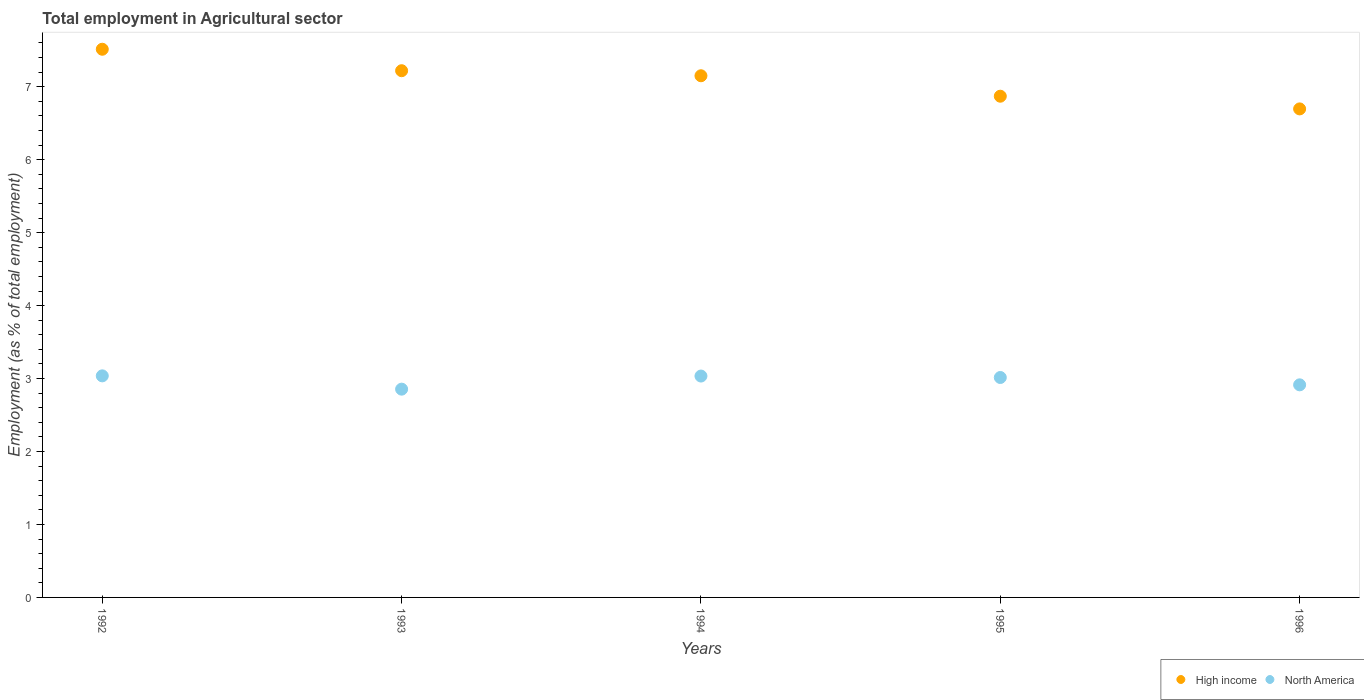How many different coloured dotlines are there?
Your answer should be compact. 2. Is the number of dotlines equal to the number of legend labels?
Provide a short and direct response. Yes. What is the employment in agricultural sector in High income in 1994?
Your response must be concise. 7.15. Across all years, what is the maximum employment in agricultural sector in North America?
Your answer should be compact. 3.04. Across all years, what is the minimum employment in agricultural sector in High income?
Keep it short and to the point. 6.7. What is the total employment in agricultural sector in North America in the graph?
Offer a terse response. 14.85. What is the difference between the employment in agricultural sector in High income in 1993 and that in 1994?
Offer a very short reply. 0.07. What is the difference between the employment in agricultural sector in High income in 1993 and the employment in agricultural sector in North America in 1995?
Your answer should be very brief. 4.21. What is the average employment in agricultural sector in North America per year?
Offer a terse response. 2.97. In the year 1993, what is the difference between the employment in agricultural sector in High income and employment in agricultural sector in North America?
Keep it short and to the point. 4.36. What is the ratio of the employment in agricultural sector in North America in 1992 to that in 1994?
Your answer should be compact. 1. What is the difference between the highest and the second highest employment in agricultural sector in North America?
Your answer should be compact. 0. What is the difference between the highest and the lowest employment in agricultural sector in High income?
Provide a short and direct response. 0.82. In how many years, is the employment in agricultural sector in High income greater than the average employment in agricultural sector in High income taken over all years?
Offer a terse response. 3. How many years are there in the graph?
Provide a short and direct response. 5. What is the difference between two consecutive major ticks on the Y-axis?
Provide a succinct answer. 1. Are the values on the major ticks of Y-axis written in scientific E-notation?
Your response must be concise. No. How many legend labels are there?
Offer a very short reply. 2. What is the title of the graph?
Ensure brevity in your answer.  Total employment in Agricultural sector. What is the label or title of the Y-axis?
Offer a very short reply. Employment (as % of total employment). What is the Employment (as % of total employment) in High income in 1992?
Provide a short and direct response. 7.51. What is the Employment (as % of total employment) in North America in 1992?
Keep it short and to the point. 3.04. What is the Employment (as % of total employment) of High income in 1993?
Ensure brevity in your answer.  7.22. What is the Employment (as % of total employment) of North America in 1993?
Make the answer very short. 2.85. What is the Employment (as % of total employment) of High income in 1994?
Provide a short and direct response. 7.15. What is the Employment (as % of total employment) in North America in 1994?
Your answer should be compact. 3.03. What is the Employment (as % of total employment) in High income in 1995?
Give a very brief answer. 6.87. What is the Employment (as % of total employment) in North America in 1995?
Give a very brief answer. 3.01. What is the Employment (as % of total employment) in High income in 1996?
Keep it short and to the point. 6.7. What is the Employment (as % of total employment) in North America in 1996?
Offer a very short reply. 2.91. Across all years, what is the maximum Employment (as % of total employment) in High income?
Keep it short and to the point. 7.51. Across all years, what is the maximum Employment (as % of total employment) of North America?
Provide a succinct answer. 3.04. Across all years, what is the minimum Employment (as % of total employment) of High income?
Your response must be concise. 6.7. Across all years, what is the minimum Employment (as % of total employment) of North America?
Keep it short and to the point. 2.85. What is the total Employment (as % of total employment) of High income in the graph?
Your answer should be very brief. 35.45. What is the total Employment (as % of total employment) in North America in the graph?
Your answer should be very brief. 14.85. What is the difference between the Employment (as % of total employment) in High income in 1992 and that in 1993?
Give a very brief answer. 0.29. What is the difference between the Employment (as % of total employment) of North America in 1992 and that in 1993?
Offer a very short reply. 0.18. What is the difference between the Employment (as % of total employment) in High income in 1992 and that in 1994?
Provide a succinct answer. 0.36. What is the difference between the Employment (as % of total employment) of North America in 1992 and that in 1994?
Your answer should be very brief. 0. What is the difference between the Employment (as % of total employment) of High income in 1992 and that in 1995?
Keep it short and to the point. 0.64. What is the difference between the Employment (as % of total employment) in North America in 1992 and that in 1995?
Your response must be concise. 0.02. What is the difference between the Employment (as % of total employment) of High income in 1992 and that in 1996?
Your response must be concise. 0.82. What is the difference between the Employment (as % of total employment) of North America in 1992 and that in 1996?
Provide a succinct answer. 0.12. What is the difference between the Employment (as % of total employment) in High income in 1993 and that in 1994?
Offer a very short reply. 0.07. What is the difference between the Employment (as % of total employment) of North America in 1993 and that in 1994?
Offer a terse response. -0.18. What is the difference between the Employment (as % of total employment) in High income in 1993 and that in 1995?
Make the answer very short. 0.35. What is the difference between the Employment (as % of total employment) in North America in 1993 and that in 1995?
Offer a terse response. -0.16. What is the difference between the Employment (as % of total employment) of High income in 1993 and that in 1996?
Your answer should be compact. 0.52. What is the difference between the Employment (as % of total employment) of North America in 1993 and that in 1996?
Offer a terse response. -0.06. What is the difference between the Employment (as % of total employment) in High income in 1994 and that in 1995?
Your response must be concise. 0.28. What is the difference between the Employment (as % of total employment) in North America in 1994 and that in 1995?
Offer a very short reply. 0.02. What is the difference between the Employment (as % of total employment) in High income in 1994 and that in 1996?
Your response must be concise. 0.45. What is the difference between the Employment (as % of total employment) in North America in 1994 and that in 1996?
Your answer should be very brief. 0.12. What is the difference between the Employment (as % of total employment) of High income in 1995 and that in 1996?
Keep it short and to the point. 0.17. What is the difference between the Employment (as % of total employment) in North America in 1995 and that in 1996?
Ensure brevity in your answer.  0.1. What is the difference between the Employment (as % of total employment) of High income in 1992 and the Employment (as % of total employment) of North America in 1993?
Offer a terse response. 4.66. What is the difference between the Employment (as % of total employment) of High income in 1992 and the Employment (as % of total employment) of North America in 1994?
Your response must be concise. 4.48. What is the difference between the Employment (as % of total employment) of High income in 1992 and the Employment (as % of total employment) of North America in 1995?
Your response must be concise. 4.5. What is the difference between the Employment (as % of total employment) of High income in 1992 and the Employment (as % of total employment) of North America in 1996?
Make the answer very short. 4.6. What is the difference between the Employment (as % of total employment) in High income in 1993 and the Employment (as % of total employment) in North America in 1994?
Make the answer very short. 4.19. What is the difference between the Employment (as % of total employment) of High income in 1993 and the Employment (as % of total employment) of North America in 1995?
Keep it short and to the point. 4.21. What is the difference between the Employment (as % of total employment) in High income in 1993 and the Employment (as % of total employment) in North America in 1996?
Ensure brevity in your answer.  4.31. What is the difference between the Employment (as % of total employment) in High income in 1994 and the Employment (as % of total employment) in North America in 1995?
Make the answer very short. 4.14. What is the difference between the Employment (as % of total employment) of High income in 1994 and the Employment (as % of total employment) of North America in 1996?
Provide a succinct answer. 4.24. What is the difference between the Employment (as % of total employment) of High income in 1995 and the Employment (as % of total employment) of North America in 1996?
Make the answer very short. 3.96. What is the average Employment (as % of total employment) in High income per year?
Your response must be concise. 7.09. What is the average Employment (as % of total employment) in North America per year?
Ensure brevity in your answer.  2.97. In the year 1992, what is the difference between the Employment (as % of total employment) in High income and Employment (as % of total employment) in North America?
Ensure brevity in your answer.  4.48. In the year 1993, what is the difference between the Employment (as % of total employment) of High income and Employment (as % of total employment) of North America?
Offer a terse response. 4.36. In the year 1994, what is the difference between the Employment (as % of total employment) in High income and Employment (as % of total employment) in North America?
Offer a terse response. 4.12. In the year 1995, what is the difference between the Employment (as % of total employment) in High income and Employment (as % of total employment) in North America?
Offer a terse response. 3.86. In the year 1996, what is the difference between the Employment (as % of total employment) of High income and Employment (as % of total employment) of North America?
Ensure brevity in your answer.  3.78. What is the ratio of the Employment (as % of total employment) of High income in 1992 to that in 1993?
Your answer should be very brief. 1.04. What is the ratio of the Employment (as % of total employment) of North America in 1992 to that in 1993?
Your response must be concise. 1.06. What is the ratio of the Employment (as % of total employment) of High income in 1992 to that in 1994?
Offer a terse response. 1.05. What is the ratio of the Employment (as % of total employment) of High income in 1992 to that in 1995?
Provide a succinct answer. 1.09. What is the ratio of the Employment (as % of total employment) in North America in 1992 to that in 1995?
Your response must be concise. 1.01. What is the ratio of the Employment (as % of total employment) in High income in 1992 to that in 1996?
Your answer should be compact. 1.12. What is the ratio of the Employment (as % of total employment) of North America in 1992 to that in 1996?
Ensure brevity in your answer.  1.04. What is the ratio of the Employment (as % of total employment) in High income in 1993 to that in 1994?
Keep it short and to the point. 1.01. What is the ratio of the Employment (as % of total employment) of North America in 1993 to that in 1994?
Give a very brief answer. 0.94. What is the ratio of the Employment (as % of total employment) in High income in 1993 to that in 1995?
Ensure brevity in your answer.  1.05. What is the ratio of the Employment (as % of total employment) of North America in 1993 to that in 1995?
Ensure brevity in your answer.  0.95. What is the ratio of the Employment (as % of total employment) in High income in 1993 to that in 1996?
Offer a very short reply. 1.08. What is the ratio of the Employment (as % of total employment) in North America in 1993 to that in 1996?
Your response must be concise. 0.98. What is the ratio of the Employment (as % of total employment) in High income in 1994 to that in 1995?
Provide a short and direct response. 1.04. What is the ratio of the Employment (as % of total employment) in High income in 1994 to that in 1996?
Keep it short and to the point. 1.07. What is the ratio of the Employment (as % of total employment) of North America in 1994 to that in 1996?
Offer a very short reply. 1.04. What is the ratio of the Employment (as % of total employment) in High income in 1995 to that in 1996?
Provide a short and direct response. 1.03. What is the ratio of the Employment (as % of total employment) in North America in 1995 to that in 1996?
Your answer should be compact. 1.03. What is the difference between the highest and the second highest Employment (as % of total employment) in High income?
Offer a terse response. 0.29. What is the difference between the highest and the second highest Employment (as % of total employment) of North America?
Provide a succinct answer. 0. What is the difference between the highest and the lowest Employment (as % of total employment) in High income?
Make the answer very short. 0.82. What is the difference between the highest and the lowest Employment (as % of total employment) in North America?
Provide a short and direct response. 0.18. 